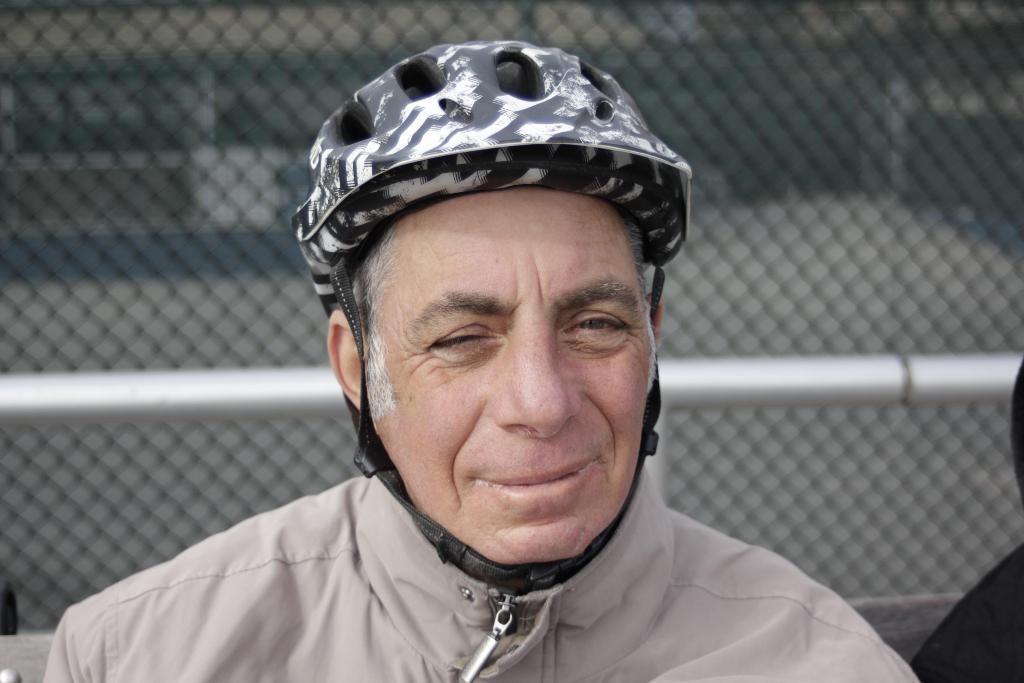Who or what is present in the image? There is a person in the image. What is the person wearing on their head? The person is wearing a helmet. What can be seen in the background of the image? There is a metal rod and wire mesh in the background of the image. What type of square object can be seen on the ground in the image? There is no square object present on the ground in the image. 